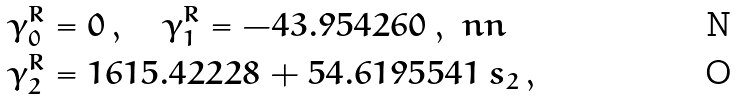<formula> <loc_0><loc_0><loc_500><loc_500>\gamma _ { 0 } ^ { R } & = 0 \, , \quad \gamma _ { 1 } ^ { R } = - 4 3 . 9 5 4 2 6 0 \, , \ n n \\ \gamma _ { 2 } ^ { R } & = 1 6 1 5 . 4 2 2 2 8 + 5 4 . 6 1 9 5 5 4 1 \, s _ { 2 } \, ,</formula> 